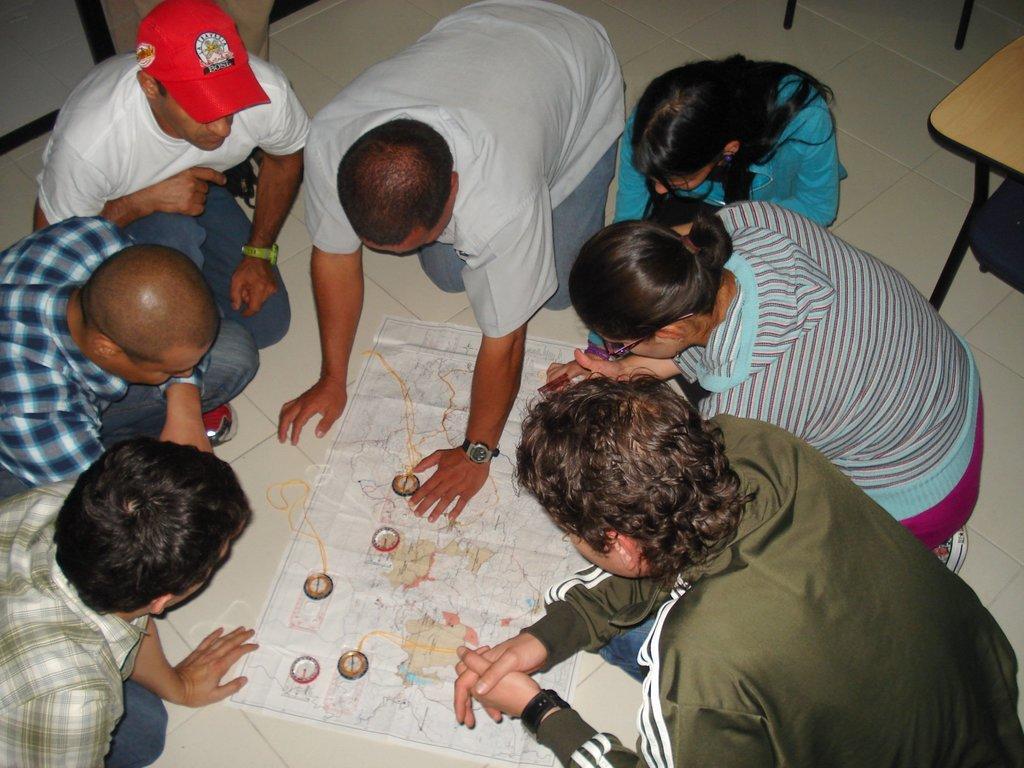Describe this image in one or two sentences. There is a map on the floor. Around that there are many people. Person on the top left corner is wearing a cap. 